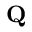<formula> <loc_0><loc_0><loc_500><loc_500>{ Q }</formula> 